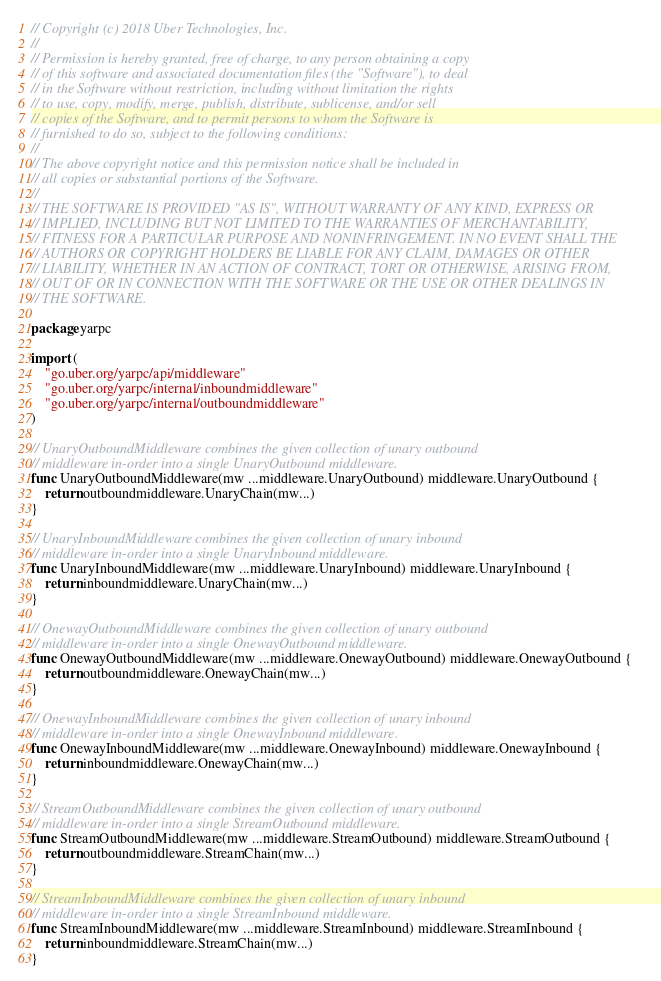<code> <loc_0><loc_0><loc_500><loc_500><_Go_>// Copyright (c) 2018 Uber Technologies, Inc.
//
// Permission is hereby granted, free of charge, to any person obtaining a copy
// of this software and associated documentation files (the "Software"), to deal
// in the Software without restriction, including without limitation the rights
// to use, copy, modify, merge, publish, distribute, sublicense, and/or sell
// copies of the Software, and to permit persons to whom the Software is
// furnished to do so, subject to the following conditions:
//
// The above copyright notice and this permission notice shall be included in
// all copies or substantial portions of the Software.
//
// THE SOFTWARE IS PROVIDED "AS IS", WITHOUT WARRANTY OF ANY KIND, EXPRESS OR
// IMPLIED, INCLUDING BUT NOT LIMITED TO THE WARRANTIES OF MERCHANTABILITY,
// FITNESS FOR A PARTICULAR PURPOSE AND NONINFRINGEMENT. IN NO EVENT SHALL THE
// AUTHORS OR COPYRIGHT HOLDERS BE LIABLE FOR ANY CLAIM, DAMAGES OR OTHER
// LIABILITY, WHETHER IN AN ACTION OF CONTRACT, TORT OR OTHERWISE, ARISING FROM,
// OUT OF OR IN CONNECTION WITH THE SOFTWARE OR THE USE OR OTHER DEALINGS IN
// THE SOFTWARE.

package yarpc

import (
	"go.uber.org/yarpc/api/middleware"
	"go.uber.org/yarpc/internal/inboundmiddleware"
	"go.uber.org/yarpc/internal/outboundmiddleware"
)

// UnaryOutboundMiddleware combines the given collection of unary outbound
// middleware in-order into a single UnaryOutbound middleware.
func UnaryOutboundMiddleware(mw ...middleware.UnaryOutbound) middleware.UnaryOutbound {
	return outboundmiddleware.UnaryChain(mw...)
}

// UnaryInboundMiddleware combines the given collection of unary inbound
// middleware in-order into a single UnaryInbound middleware.
func UnaryInboundMiddleware(mw ...middleware.UnaryInbound) middleware.UnaryInbound {
	return inboundmiddleware.UnaryChain(mw...)
}

// OnewayOutboundMiddleware combines the given collection of unary outbound
// middleware in-order into a single OnewayOutbound middleware.
func OnewayOutboundMiddleware(mw ...middleware.OnewayOutbound) middleware.OnewayOutbound {
	return outboundmiddleware.OnewayChain(mw...)
}

// OnewayInboundMiddleware combines the given collection of unary inbound
// middleware in-order into a single OnewayInbound middleware.
func OnewayInboundMiddleware(mw ...middleware.OnewayInbound) middleware.OnewayInbound {
	return inboundmiddleware.OnewayChain(mw...)
}

// StreamOutboundMiddleware combines the given collection of unary outbound
// middleware in-order into a single StreamOutbound middleware.
func StreamOutboundMiddleware(mw ...middleware.StreamOutbound) middleware.StreamOutbound {
	return outboundmiddleware.StreamChain(mw...)
}

// StreamInboundMiddleware combines the given collection of unary inbound
// middleware in-order into a single StreamInbound middleware.
func StreamInboundMiddleware(mw ...middleware.StreamInbound) middleware.StreamInbound {
	return inboundmiddleware.StreamChain(mw...)
}
</code> 